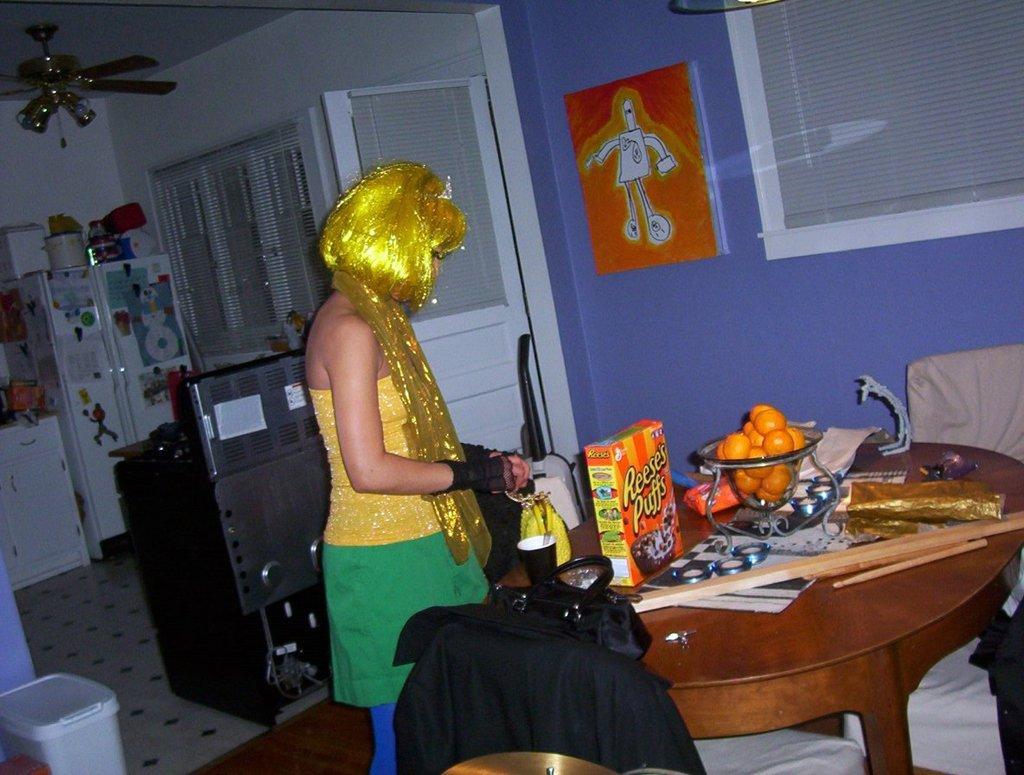Could you give a brief overview of what you see in this image? A woman is standing at a table. There are fruits,a pack box and cup on the table. She has a golden color hair and wears gold color scarf with a top. There is painting on the wall beside a window. There are refrigerator,washing machine and ceiling fan in the background. 